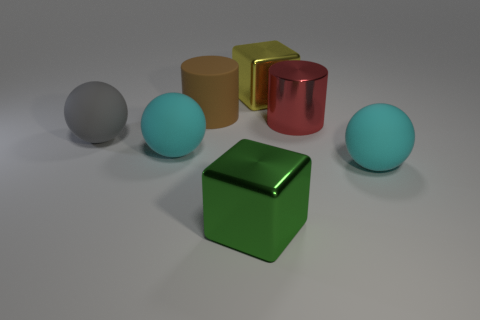How many other big shiny things have the same shape as the brown object?
Ensure brevity in your answer.  1. Do the big green cube and the block that is behind the gray matte ball have the same material?
Your response must be concise. Yes. There is a yellow cube that is the same size as the gray ball; what material is it?
Your answer should be very brief. Metal. Is there a green matte cylinder of the same size as the brown object?
Give a very brief answer. No. What is the shape of the green metal thing that is the same size as the brown cylinder?
Your answer should be very brief. Cube. How many other objects are the same color as the metal cylinder?
Your response must be concise. 0. There is a big thing that is both on the left side of the big brown cylinder and to the right of the gray rubber ball; what shape is it?
Make the answer very short. Sphere. Are there any large cylinders in front of the large cyan sphere that is behind the ball right of the big green cube?
Ensure brevity in your answer.  No. What number of other objects are there of the same material as the large brown object?
Make the answer very short. 3. How many green cubes are there?
Your answer should be very brief. 1. 